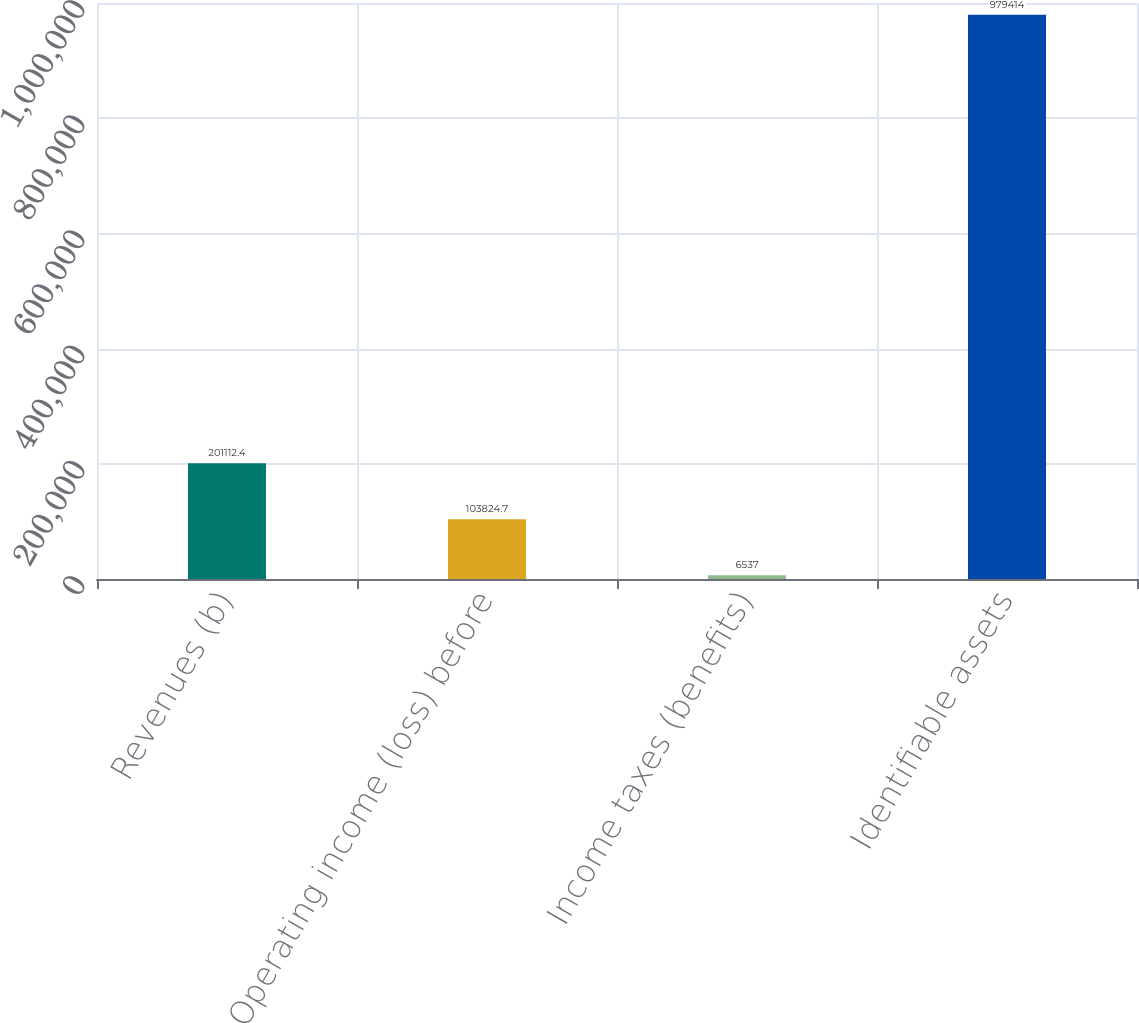<chart> <loc_0><loc_0><loc_500><loc_500><bar_chart><fcel>Revenues (b)<fcel>Operating income (loss) before<fcel>Income taxes (benefits)<fcel>Identifiable assets<nl><fcel>201112<fcel>103825<fcel>6537<fcel>979414<nl></chart> 